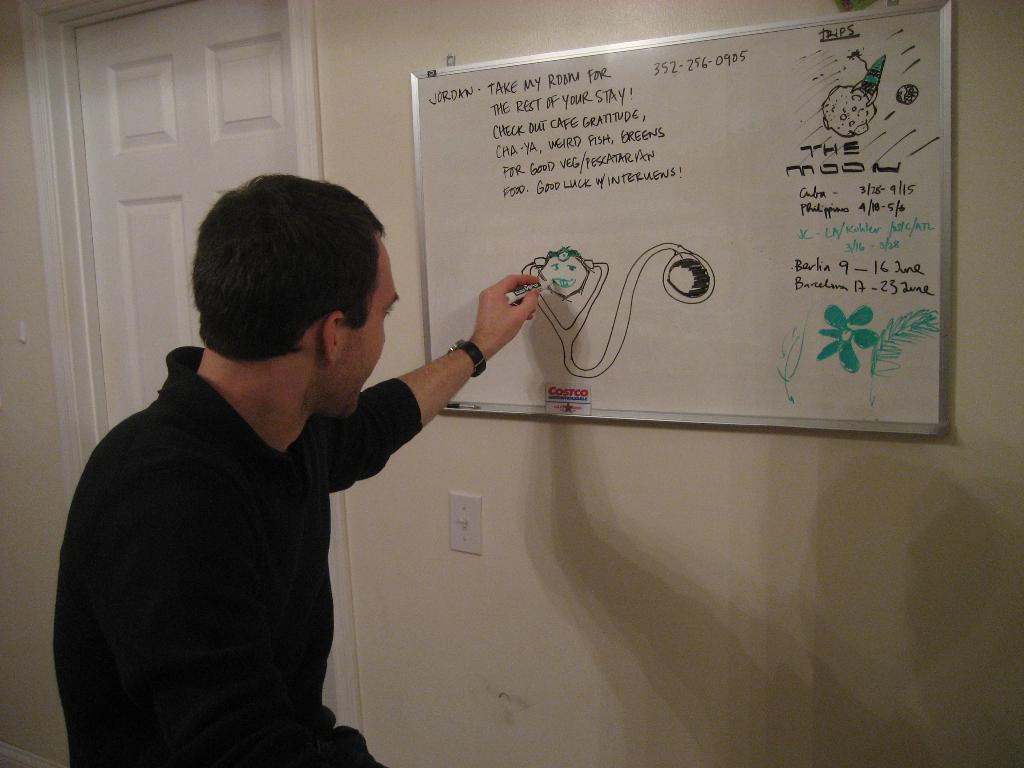Provide a one-sentence caption for the provided image. A man drawing on a white board that says Jordan take my room for the rest of your stay!. 